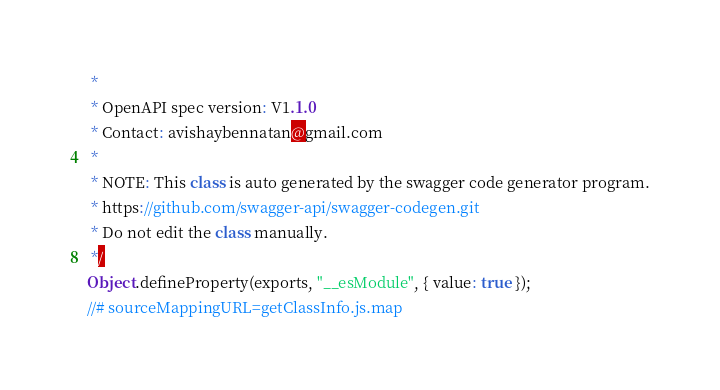Convert code to text. <code><loc_0><loc_0><loc_500><loc_500><_JavaScript_> *
 * OpenAPI spec version: V1.1.0
 * Contact: avishaybennatan@gmail.com
 *
 * NOTE: This class is auto generated by the swagger code generator program.
 * https://github.com/swagger-api/swagger-codegen.git
 * Do not edit the class manually.
 */
Object.defineProperty(exports, "__esModule", { value: true });
//# sourceMappingURL=getClassInfo.js.map</code> 